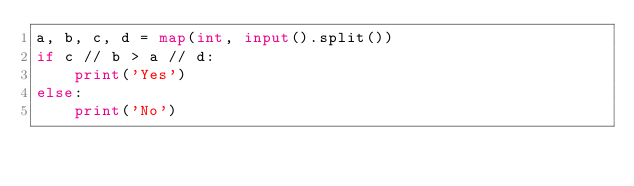<code> <loc_0><loc_0><loc_500><loc_500><_Python_>a, b, c, d = map(int, input().split())
if c // b > a // d:
    print('Yes')
else:
    print('No')</code> 